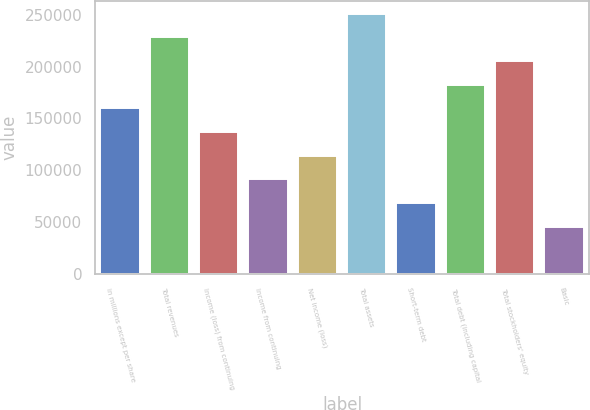<chart> <loc_0><loc_0><loc_500><loc_500><bar_chart><fcel>in millions except per share<fcel>Total revenues<fcel>Income (loss) from continuing<fcel>Income from continuing<fcel>Net income (loss)<fcel>Total assets<fcel>Short-term debt<fcel>Total debt (including capital<fcel>Total stockholders' equity<fcel>Basic<nl><fcel>159844<fcel>228348<fcel>137009<fcel>91339.7<fcel>114174<fcel>251183<fcel>68504.9<fcel>182679<fcel>205513<fcel>45670.2<nl></chart> 